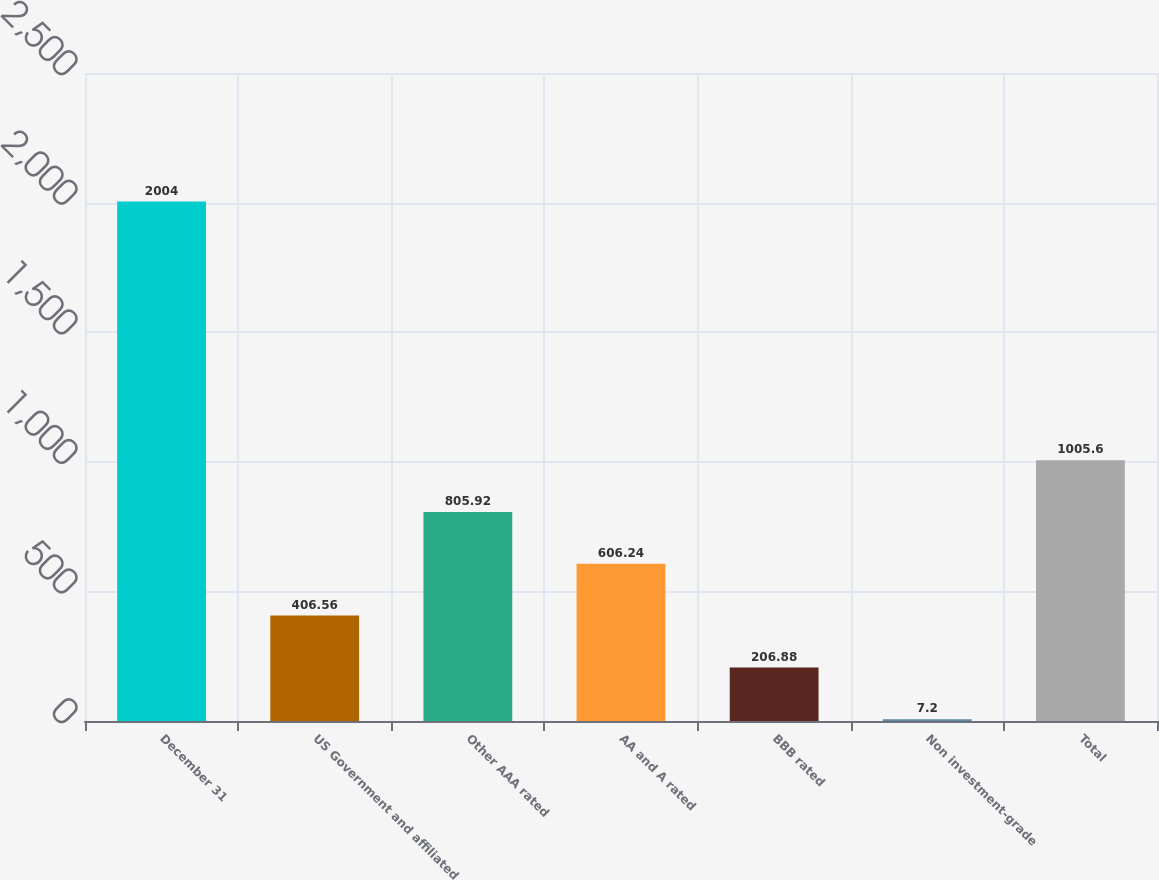<chart> <loc_0><loc_0><loc_500><loc_500><bar_chart><fcel>December 31<fcel>US Government and affiliated<fcel>Other AAA rated<fcel>AA and A rated<fcel>BBB rated<fcel>Non investment-grade<fcel>Total<nl><fcel>2004<fcel>406.56<fcel>805.92<fcel>606.24<fcel>206.88<fcel>7.2<fcel>1005.6<nl></chart> 